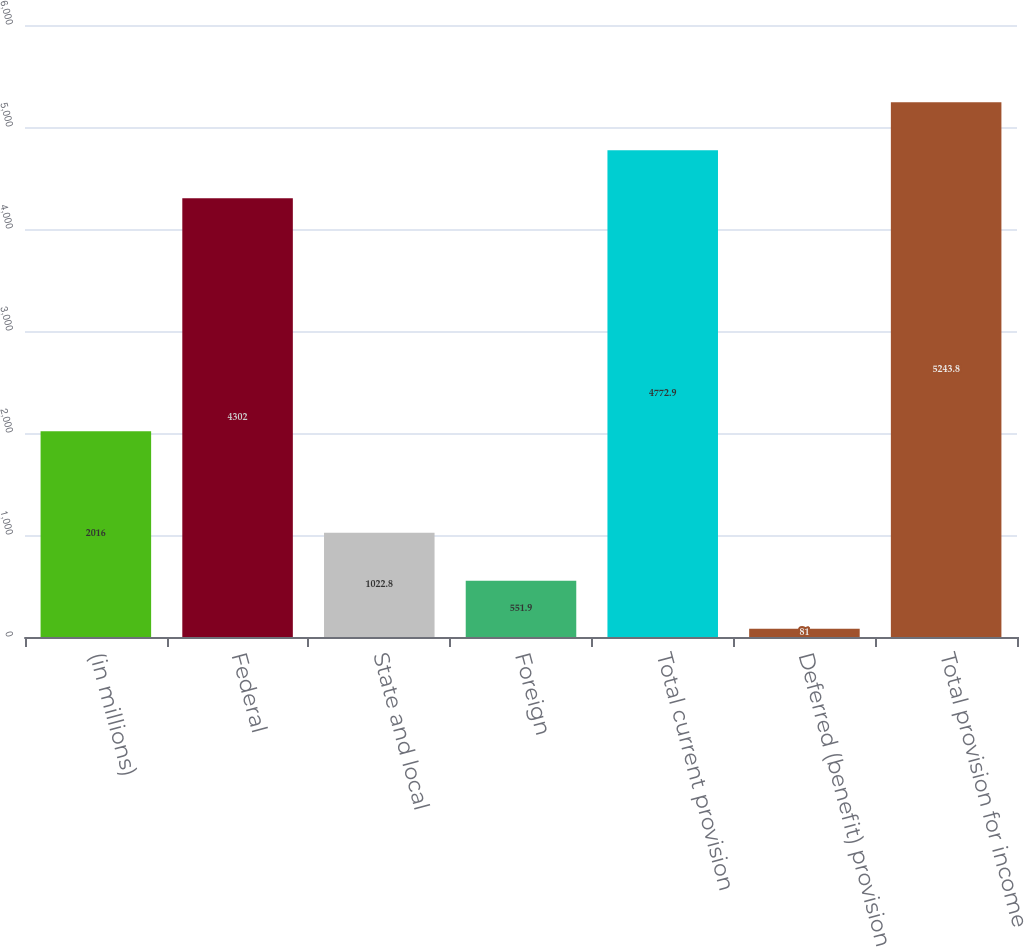<chart> <loc_0><loc_0><loc_500><loc_500><bar_chart><fcel>(in millions)<fcel>Federal<fcel>State and local<fcel>Foreign<fcel>Total current provision<fcel>Deferred (benefit) provision<fcel>Total provision for income<nl><fcel>2016<fcel>4302<fcel>1022.8<fcel>551.9<fcel>4772.9<fcel>81<fcel>5243.8<nl></chart> 